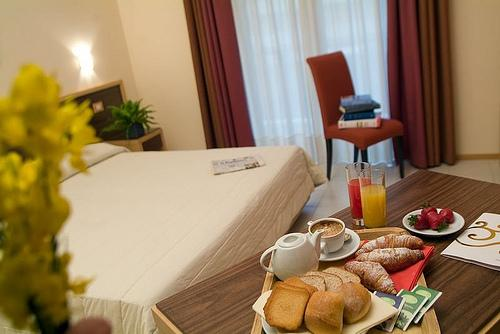What items can be found on the tray? Baked goods, 3 packets, bread, rolls, croissants sprinkled with powdered sugar, and slices of bread. What kinds of food items can be seen in the image? Strawberries, bread, rolls, croissants sprinkled with powdered sugar, and baked goods on a tray. List the various items placed on the nightstand. There are no specific items mentioned on the nightstand. Provide a short description of the items found on the bed. A folded newspaper can be seen on the bed with a white cover. How many different types of plants and flowers are visible in the image? Two types: a potted plant and yellow flowers. Can you provide a brief description of the bed in the image? The bed has a white cover, and there is a folded newspaper on it. Identify two beverages present in the image and describe their glasses. Orange juice in a tall glass and tomato juice in a slightly shorter glass. Provide a caption for the image that includes the main food items. A delightful breakfast spread featuring a tray of baked goods, a plate of red strawberries, and two tall glasses of juice. Describe the lighting in the image. The light on the wall behind the bed indicates the room is well-lit. Is there a diagram to understand in this image? No, the image does not contain a diagram. Which object has three packets on it? tray Read the text on the three green bags found in the image. tea What type of juice is in the taller glass? orange juice Compose a vivid and atmospheric description involving the bed with a white cover. A dreamy white-covered bed nestles into the sunlight-filled bedroom, beckoning for a serene afternoon nap or just lounging with a good book. Is there a white saucer on the table in the image? Yes Describe a notable event that took place in the image. Someone prepared a breakfast or tea time arrangement. What can you infer about the person's plan based on the presence of a folded newspaper? The person likely intends to read the newspaper while enjoying their breakfast or tea time. Write a descriptive caption for a ceramic tea pot in the image. A white ceramic tea pot sits on a table near a tray of baked goods. Describe the chair found in the image. The chair is maroon in color and has a stack of books on it, making it a place to unwind with a good read. Create a heartwarming scene involving the bed, chair, and potted plant. A cozy bedroom with a soft bed covered in white, a maroon chair filled with books, and a vibrant potted plant with yellow flowers by the window, filling the room with warm sunlight. What activity is likely occurring based on the presence of baked goods, tea, fruit, and juice? breakfast or tea time Explain the layout of objects in the image. There's a bed with a white cover, a nightstand, and a red chair with books. On a table, there are various food items and drinks like baked goods, tea, strawberries, and juice. Describe the nightstand in the image. The nightstand in the image is a small wooden piece of furniture with a potted plant on top. What type of baked good is sprinkled with powdered sugar? croissants 